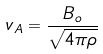Convert formula to latex. <formula><loc_0><loc_0><loc_500><loc_500>v _ { A } = \frac { B _ { o } } { \sqrt { 4 \pi \rho } }</formula> 